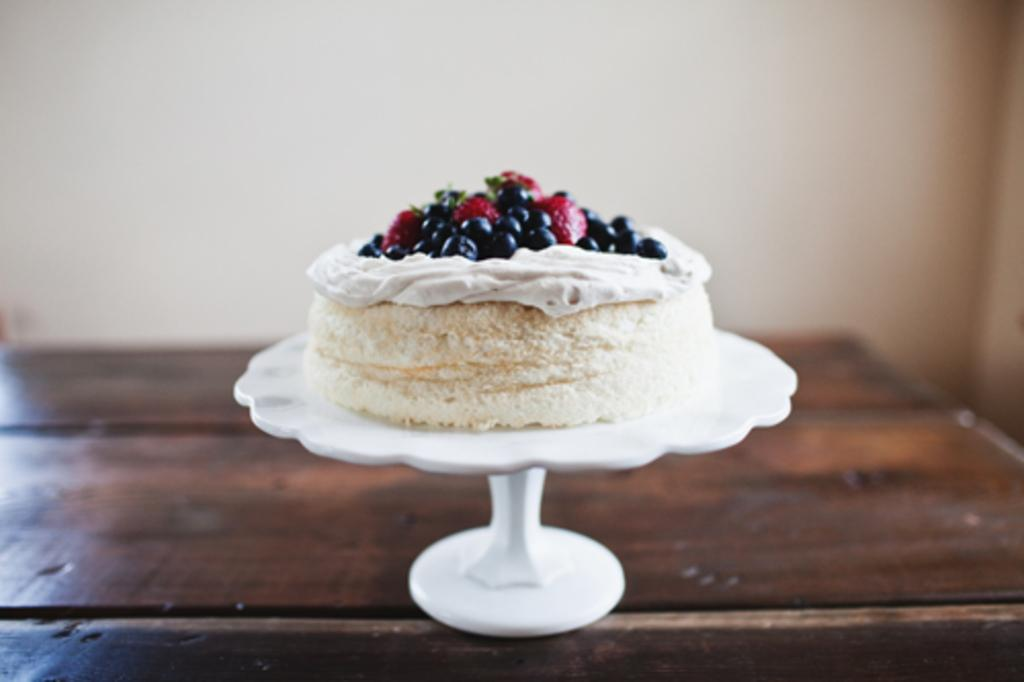Where was the image taken? The image was taken inside a room. What furniture is present in the image? There is a table in the image. What is on the table? There is a stand on the table. What is on the stand? There is a cake on the stand. What can be seen in the background of the image? There is a wall visible in the background of the image. What type of brush is used to paint the chair in the image? There is no chair or brush present in the image; it features a table with a stand and a cake. 